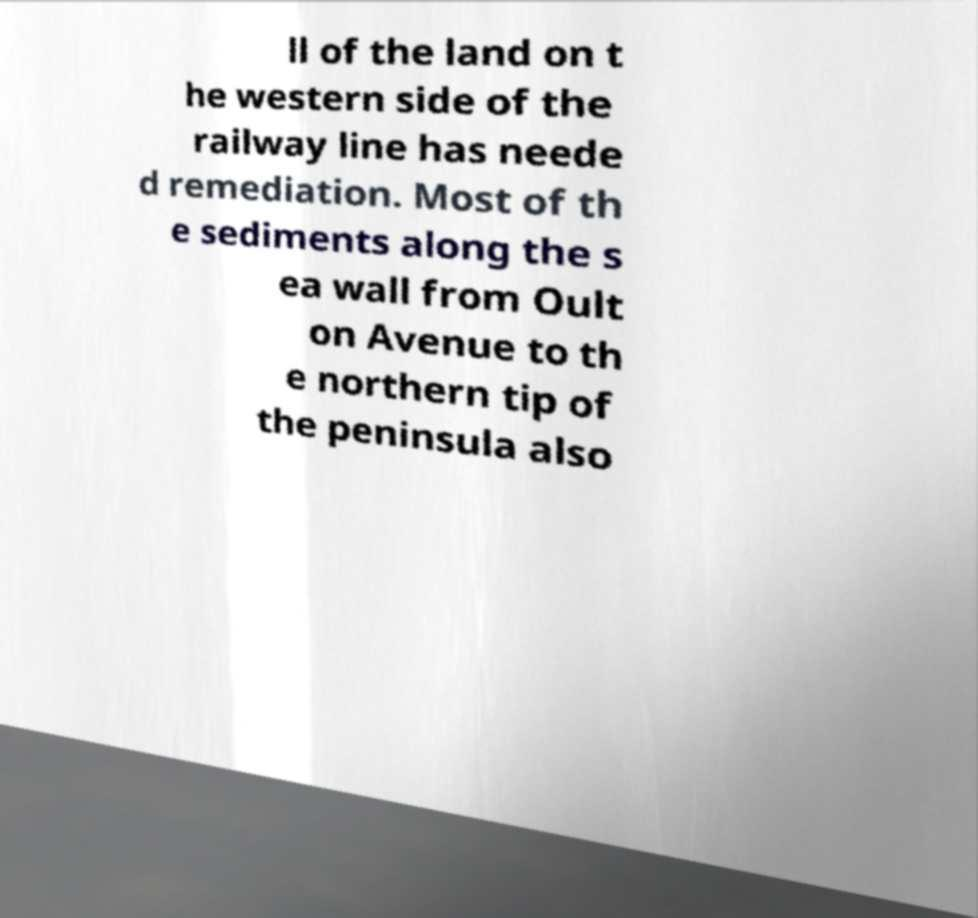What messages or text are displayed in this image? I need them in a readable, typed format. ll of the land on t he western side of the railway line has neede d remediation. Most of th e sediments along the s ea wall from Oult on Avenue to th e northern tip of the peninsula also 